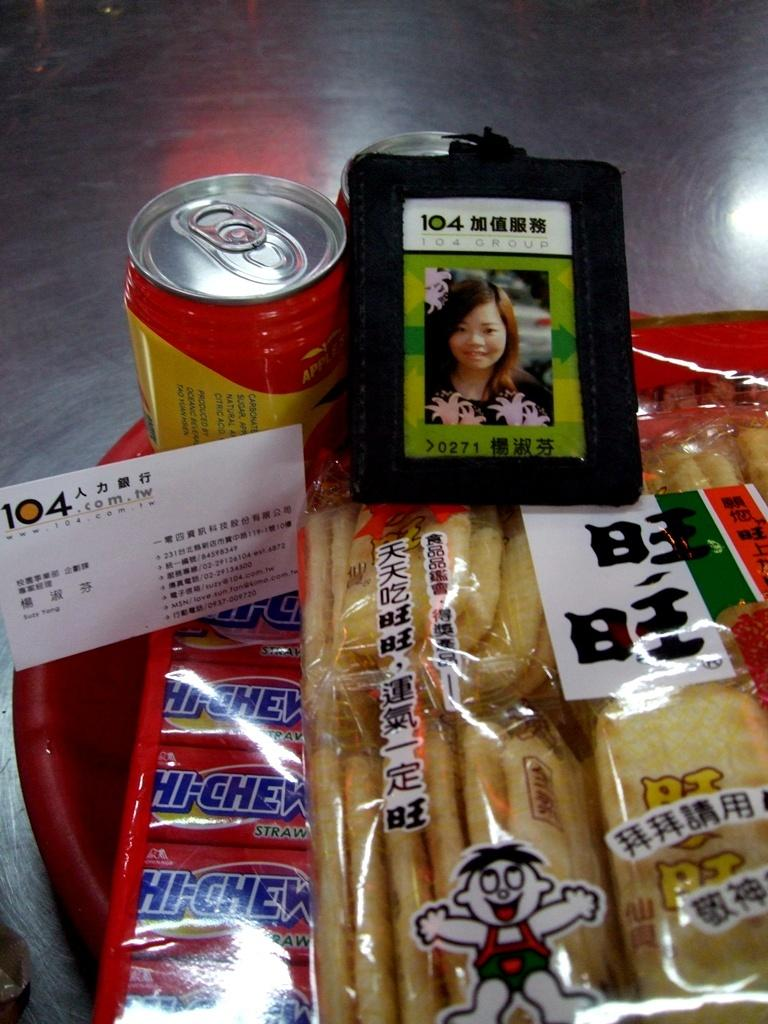What object is present in the image that can hold items? There is a basket in the image. What is inside the basket? The basket is full of chips packets and contains soft drinks. Is there any identification present in the image? Yes, there is an ID card on the basket. What type of smell can be detected from the image? There is no information about the smell in the image, so it cannot be determined. 